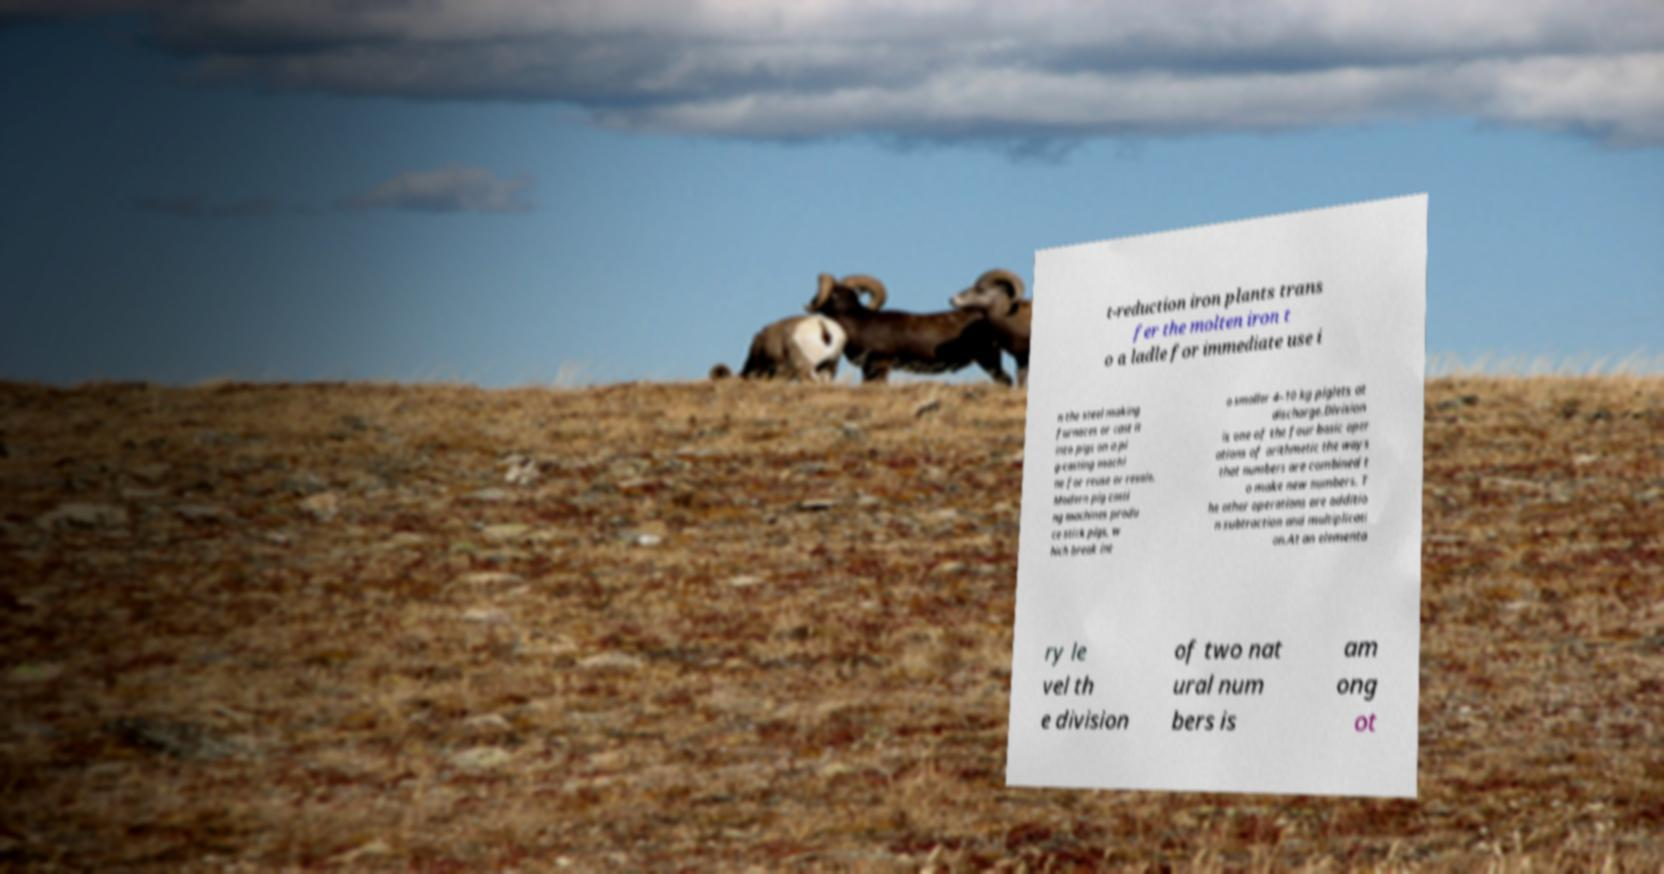There's text embedded in this image that I need extracted. Can you transcribe it verbatim? t-reduction iron plants trans fer the molten iron t o a ladle for immediate use i n the steel making furnaces or cast it into pigs on a pi g-casting machi ne for reuse or resale. Modern pig casti ng machines produ ce stick pigs, w hich break int o smaller 4–10 kg piglets at discharge.Division is one of the four basic oper ations of arithmetic the ways that numbers are combined t o make new numbers. T he other operations are additio n subtraction and multiplicati on.At an elementa ry le vel th e division of two nat ural num bers is am ong ot 